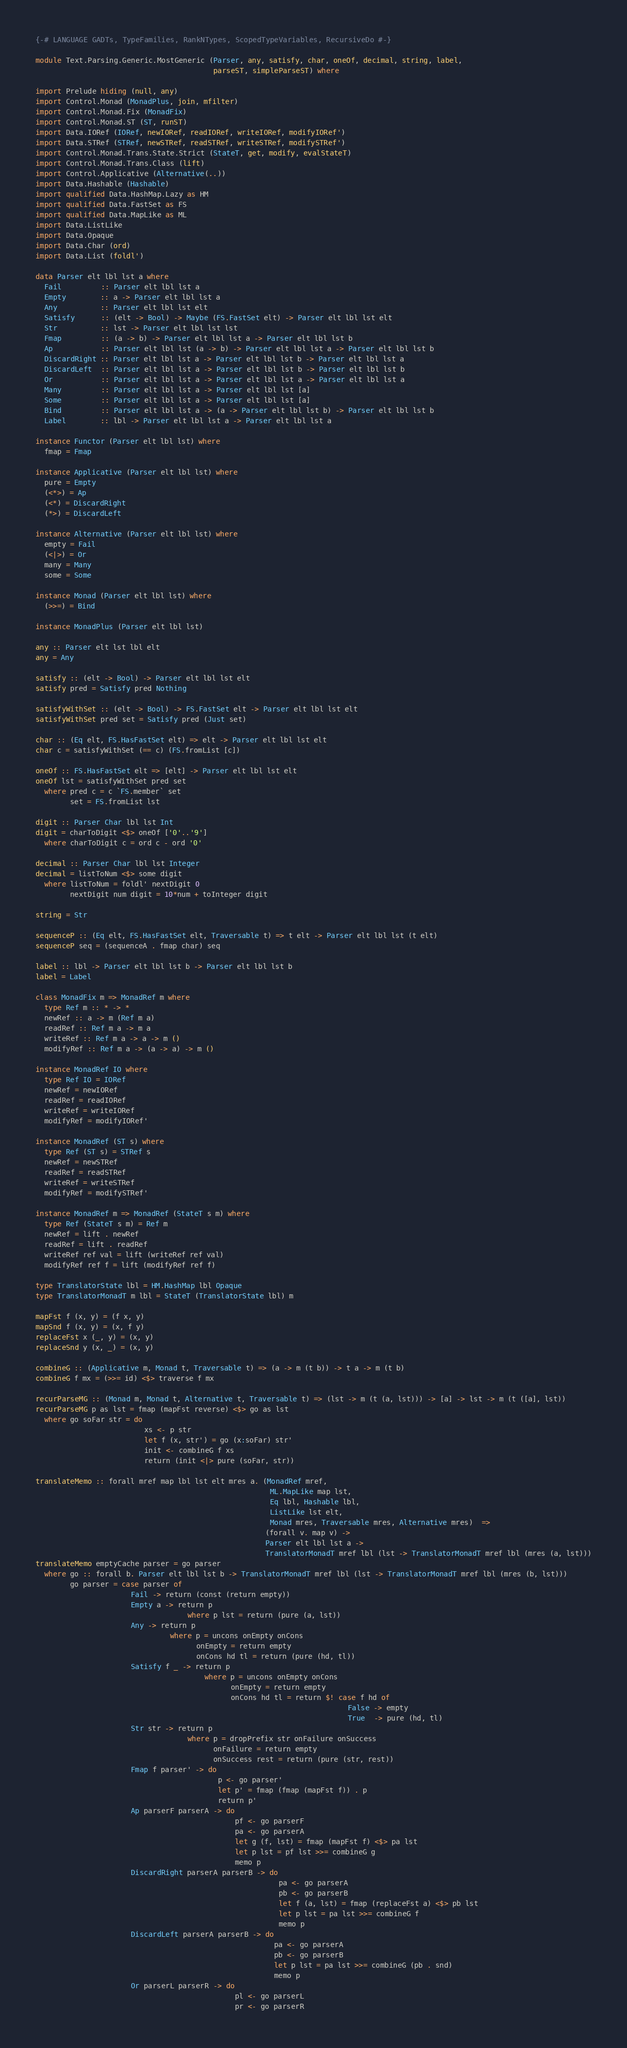Convert code to text. <code><loc_0><loc_0><loc_500><loc_500><_Haskell_>{-# LANGUAGE GADTs, TypeFamilies, RankNTypes, ScopedTypeVariables, RecursiveDo #-}

module Text.Parsing.Generic.MostGeneric (Parser, any, satisfy, char, oneOf, decimal, string, label,
                                         parseST, simpleParseST) where 

import Prelude hiding (null, any)
import Control.Monad (MonadPlus, join, mfilter)
import Control.Monad.Fix (MonadFix)
import Control.Monad.ST (ST, runST)
import Data.IORef (IORef, newIORef, readIORef, writeIORef, modifyIORef')
import Data.STRef (STRef, newSTRef, readSTRef, writeSTRef, modifySTRef')
import Control.Monad.Trans.State.Strict (StateT, get, modify, evalStateT)
import Control.Monad.Trans.Class (lift)
import Control.Applicative (Alternative(..))
import Data.Hashable (Hashable)
import qualified Data.HashMap.Lazy as HM
import qualified Data.FastSet as FS
import qualified Data.MapLike as ML
import Data.ListLike
import Data.Opaque
import Data.Char (ord)
import Data.List (foldl')

data Parser elt lbl lst a where
  Fail         :: Parser elt lbl lst a
  Empty        :: a -> Parser elt lbl lst a
  Any          :: Parser elt lbl lst elt
  Satisfy      :: (elt -> Bool) -> Maybe (FS.FastSet elt) -> Parser elt lbl lst elt
  Str          :: lst -> Parser elt lbl lst lst
  Fmap         :: (a -> b) -> Parser elt lbl lst a -> Parser elt lbl lst b
  Ap           :: Parser elt lbl lst (a -> b) -> Parser elt lbl lst a -> Parser elt lbl lst b
  DiscardRight :: Parser elt lbl lst a -> Parser elt lbl lst b -> Parser elt lbl lst a
  DiscardLeft  :: Parser elt lbl lst a -> Parser elt lbl lst b -> Parser elt lbl lst b
  Or           :: Parser elt lbl lst a -> Parser elt lbl lst a -> Parser elt lbl lst a
  Many         :: Parser elt lbl lst a -> Parser elt lbl lst [a]
  Some         :: Parser elt lbl lst a -> Parser elt lbl lst [a]
  Bind         :: Parser elt lbl lst a -> (a -> Parser elt lbl lst b) -> Parser elt lbl lst b
  Label        :: lbl -> Parser elt lbl lst a -> Parser elt lbl lst a

instance Functor (Parser elt lbl lst) where
  fmap = Fmap

instance Applicative (Parser elt lbl lst) where
  pure = Empty
  (<*>) = Ap
  (<*) = DiscardRight
  (*>) = DiscardLeft

instance Alternative (Parser elt lbl lst) where
  empty = Fail
  (<|>) = Or
  many = Many
  some = Some

instance Monad (Parser elt lbl lst) where
  (>>=) = Bind

instance MonadPlus (Parser elt lbl lst)

any :: Parser elt lst lbl elt
any = Any

satisfy :: (elt -> Bool) -> Parser elt lbl lst elt
satisfy pred = Satisfy pred Nothing

satisfyWithSet :: (elt -> Bool) -> FS.FastSet elt -> Parser elt lbl lst elt
satisfyWithSet pred set = Satisfy pred (Just set)

char :: (Eq elt, FS.HasFastSet elt) => elt -> Parser elt lbl lst elt
char c = satisfyWithSet (== c) (FS.fromList [c])

oneOf :: FS.HasFastSet elt => [elt] -> Parser elt lbl lst elt
oneOf lst = satisfyWithSet pred set
  where pred c = c `FS.member` set
        set = FS.fromList lst

digit :: Parser Char lbl lst Int
digit = charToDigit <$> oneOf ['0'..'9']
  where charToDigit c = ord c - ord '0'

decimal :: Parser Char lbl lst Integer
decimal = listToNum <$> some digit
  where listToNum = foldl' nextDigit 0
        nextDigit num digit = 10*num + toInteger digit

string = Str

sequenceP :: (Eq elt, FS.HasFastSet elt, Traversable t) => t elt -> Parser elt lbl lst (t elt)
sequenceP seq = (sequenceA . fmap char) seq

label :: lbl -> Parser elt lbl lst b -> Parser elt lbl lst b
label = Label

class MonadFix m => MonadRef m where
  type Ref m :: * -> *
  newRef :: a -> m (Ref m a)
  readRef :: Ref m a -> m a
  writeRef :: Ref m a -> a -> m ()
  modifyRef :: Ref m a -> (a -> a) -> m ()

instance MonadRef IO where
  type Ref IO = IORef
  newRef = newIORef
  readRef = readIORef
  writeRef = writeIORef
  modifyRef = modifyIORef'

instance MonadRef (ST s) where
  type Ref (ST s) = STRef s
  newRef = newSTRef
  readRef = readSTRef
  writeRef = writeSTRef
  modifyRef = modifySTRef'

instance MonadRef m => MonadRef (StateT s m) where
  type Ref (StateT s m) = Ref m
  newRef = lift . newRef
  readRef = lift . readRef
  writeRef ref val = lift (writeRef ref val)
  modifyRef ref f = lift (modifyRef ref f)

type TranslatorState lbl = HM.HashMap lbl Opaque
type TranslatorMonadT m lbl = StateT (TranslatorState lbl) m

mapFst f (x, y) = (f x, y)
mapSnd f (x, y) = (x, f y)
replaceFst x (_, y) = (x, y)
replaceSnd y (x, _) = (x, y)

combineG :: (Applicative m, Monad t, Traversable t) => (a -> m (t b)) -> t a -> m (t b)
combineG f mx = (>>= id) <$> traverse f mx

recurParseMG :: (Monad m, Monad t, Alternative t, Traversable t) => (lst -> m (t (a, lst))) -> [a] -> lst -> m (t ([a], lst)) 
recurParseMG p as lst = fmap (mapFst reverse) <$> go as lst
  where go soFar str = do
                         xs <- p str
                         let f (x, str') = go (x:soFar) str'
                         init <- combineG f xs
                         return (init <|> pure (soFar, str))
 
translateMemo :: forall mref map lbl lst elt mres a. (MonadRef mref,
                                                      ML.MapLike map lst,
                                                      Eq lbl, Hashable lbl,
                                                      ListLike lst elt,
                                                      Monad mres, Traversable mres, Alternative mres)  =>
                                                     (forall v. map v) ->
                                                     Parser elt lbl lst a ->
                                                     TranslatorMonadT mref lbl (lst -> TranslatorMonadT mref lbl (mres (a, lst)))
translateMemo emptyCache parser = go parser
  where go :: forall b. Parser elt lbl lst b -> TranslatorMonadT mref lbl (lst -> TranslatorMonadT mref lbl (mres (b, lst)))
        go parser = case parser of
                      Fail -> return (const (return empty))
                      Empty a -> return p
                                   where p lst = return (pure (a, lst))
                      Any -> return p
                               where p = uncons onEmpty onCons
                                     onEmpty = return empty
                                     onCons hd tl = return (pure (hd, tl))
                      Satisfy f _ -> return p
                                       where p = uncons onEmpty onCons
                                             onEmpty = return empty
                                             onCons hd tl = return $! case f hd of
                                                                        False -> empty
                                                                        True  -> pure (hd, tl)
                      Str str -> return p
                                   where p = dropPrefix str onFailure onSuccess
                                         onFailure = return empty
                                         onSuccess rest = return (pure (str, rest))
                      Fmap f parser' -> do
                                          p <- go parser'
                                          let p' = fmap (fmap (mapFst f)) . p
                                          return p'
                      Ap parserF parserA -> do
                                              pf <- go parserF
                                              pa <- go parserA
                                              let g (f, lst) = fmap (mapFst f) <$> pa lst
                                              let p lst = pf lst >>= combineG g
                                              memo p
                      DiscardRight parserA parserB -> do
                                                        pa <- go parserA
                                                        pb <- go parserB
                                                        let f (a, lst) = fmap (replaceFst a) <$> pb lst
                                                        let p lst = pa lst >>= combineG f
                                                        memo p
                      DiscardLeft parserA parserB -> do
                                                       pa <- go parserA
                                                       pb <- go parserB
                                                       let p lst = pa lst >>= combineG (pb . snd)
                                                       memo p
                      Or parserL parserR -> do
                                              pl <- go parserL
                                              pr <- go parserR</code> 